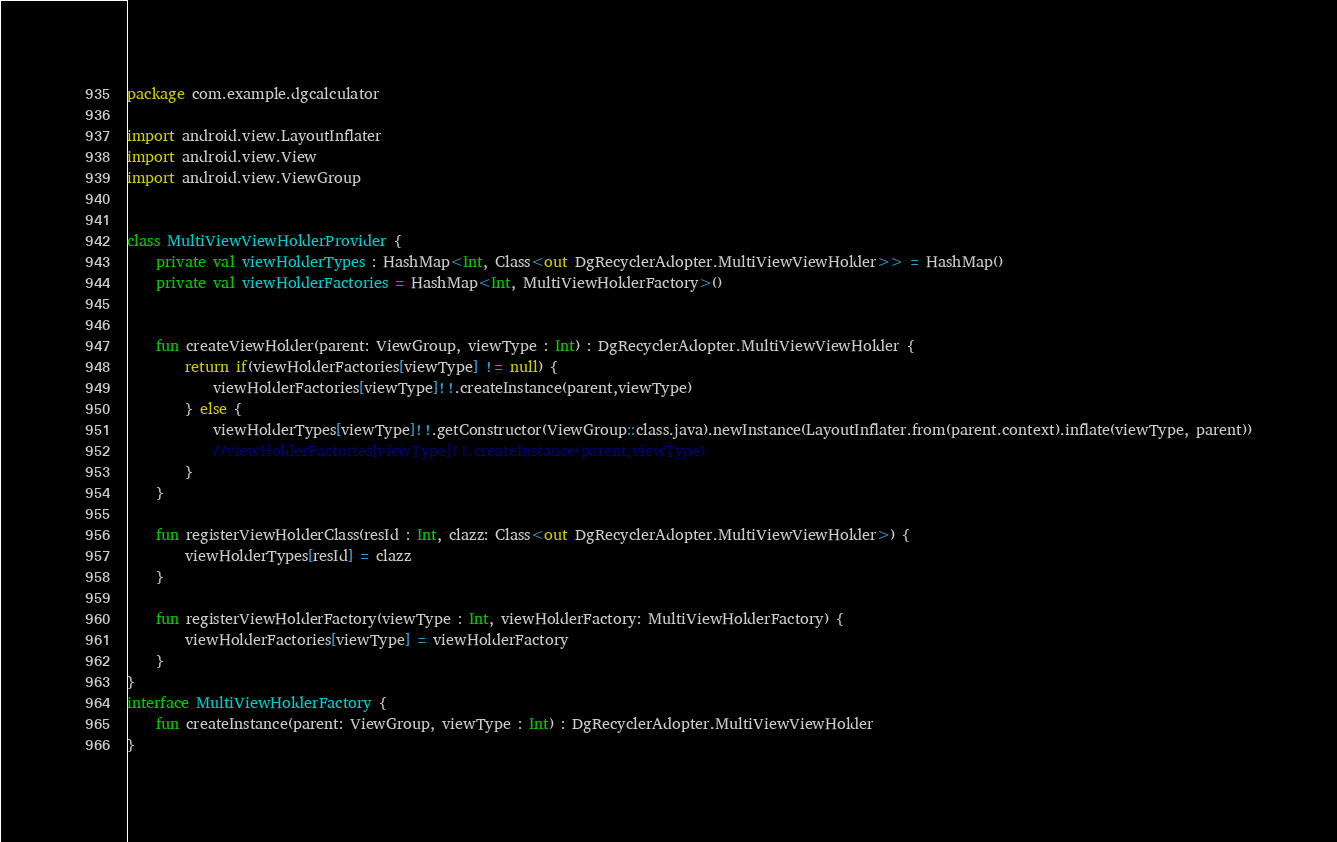<code> <loc_0><loc_0><loc_500><loc_500><_Kotlin_>package com.example.dgcalculator

import android.view.LayoutInflater
import android.view.View
import android.view.ViewGroup


class MultiViewViewHolderProvider {
    private val viewHolderTypes : HashMap<Int, Class<out DgRecyclerAdopter.MultiViewViewHolder>> = HashMap()
    private val viewHolderFactories = HashMap<Int, MultiViewHolderFactory>()


    fun createViewHolder(parent: ViewGroup, viewType : Int) : DgRecyclerAdopter.MultiViewViewHolder {
        return if(viewHolderFactories[viewType] != null) {
            viewHolderFactories[viewType]!!.createInstance(parent,viewType)
        } else {
            viewHolderTypes[viewType]!!.getConstructor(ViewGroup::class.java).newInstance(LayoutInflater.from(parent.context).inflate(viewType, parent))
            //viewHolderFactories[viewType]!!.createInstance(parent,viewType)
        }
    }

    fun registerViewHolderClass(resId : Int, clazz: Class<out DgRecyclerAdopter.MultiViewViewHolder>) {
        viewHolderTypes[resId] = clazz
    }

    fun registerViewHolderFactory(viewType : Int, viewHolderFactory: MultiViewHolderFactory) {
        viewHolderFactories[viewType] = viewHolderFactory
    }
}
interface MultiViewHolderFactory {
    fun createInstance(parent: ViewGroup, viewType : Int) : DgRecyclerAdopter.MultiViewViewHolder
}</code> 